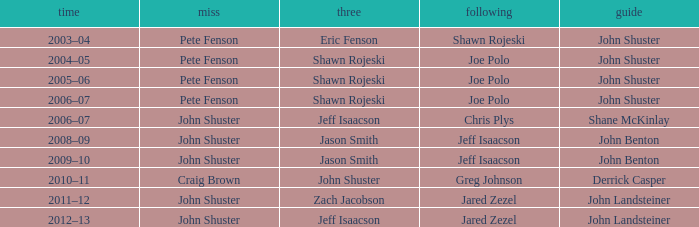Who was the lead with John Shuster as skip, Chris Plys in second, and Jeff Isaacson in third? Shane McKinlay. 